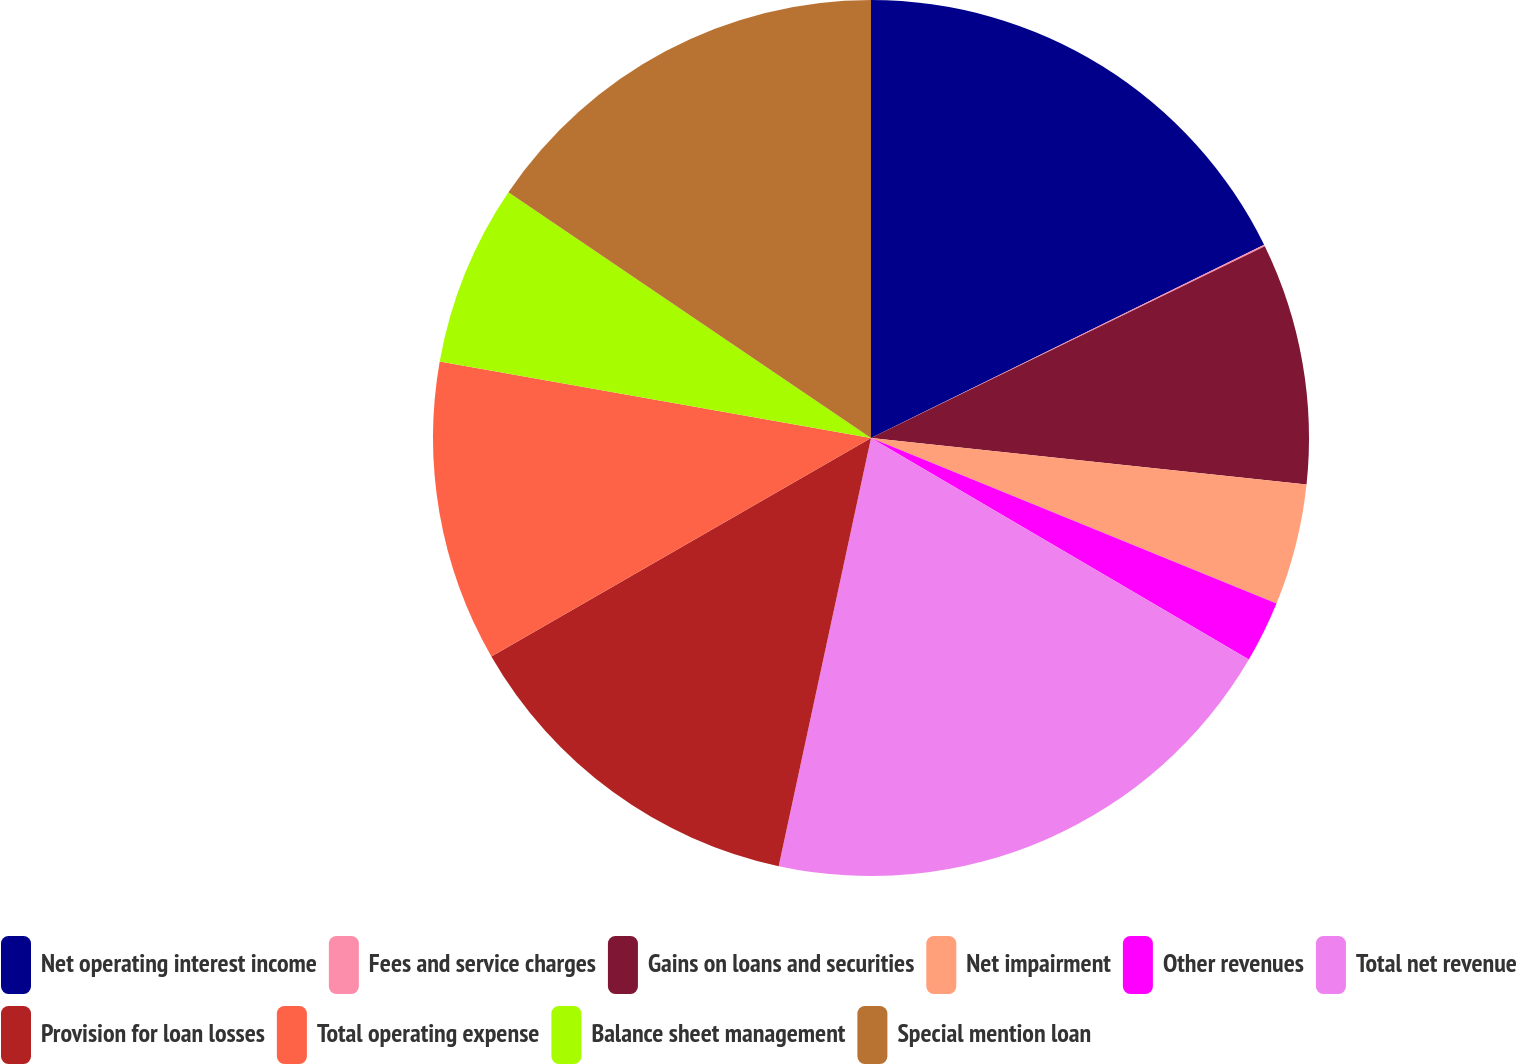Convert chart. <chart><loc_0><loc_0><loc_500><loc_500><pie_chart><fcel>Net operating interest income<fcel>Fees and service charges<fcel>Gains on loans and securities<fcel>Net impairment<fcel>Other revenues<fcel>Total net revenue<fcel>Provision for loan losses<fcel>Total operating expense<fcel>Balance sheet management<fcel>Special mention loan<nl><fcel>17.73%<fcel>0.06%<fcel>8.9%<fcel>4.48%<fcel>2.27%<fcel>19.94%<fcel>13.31%<fcel>11.1%<fcel>6.69%<fcel>15.52%<nl></chart> 